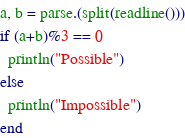Convert code to text. <code><loc_0><loc_0><loc_500><loc_500><_Julia_>a, b = parse.(split(readline()))
if (a+b)%3 == 0
  println("Possible")
else
  println("Impossible")
end
</code> 